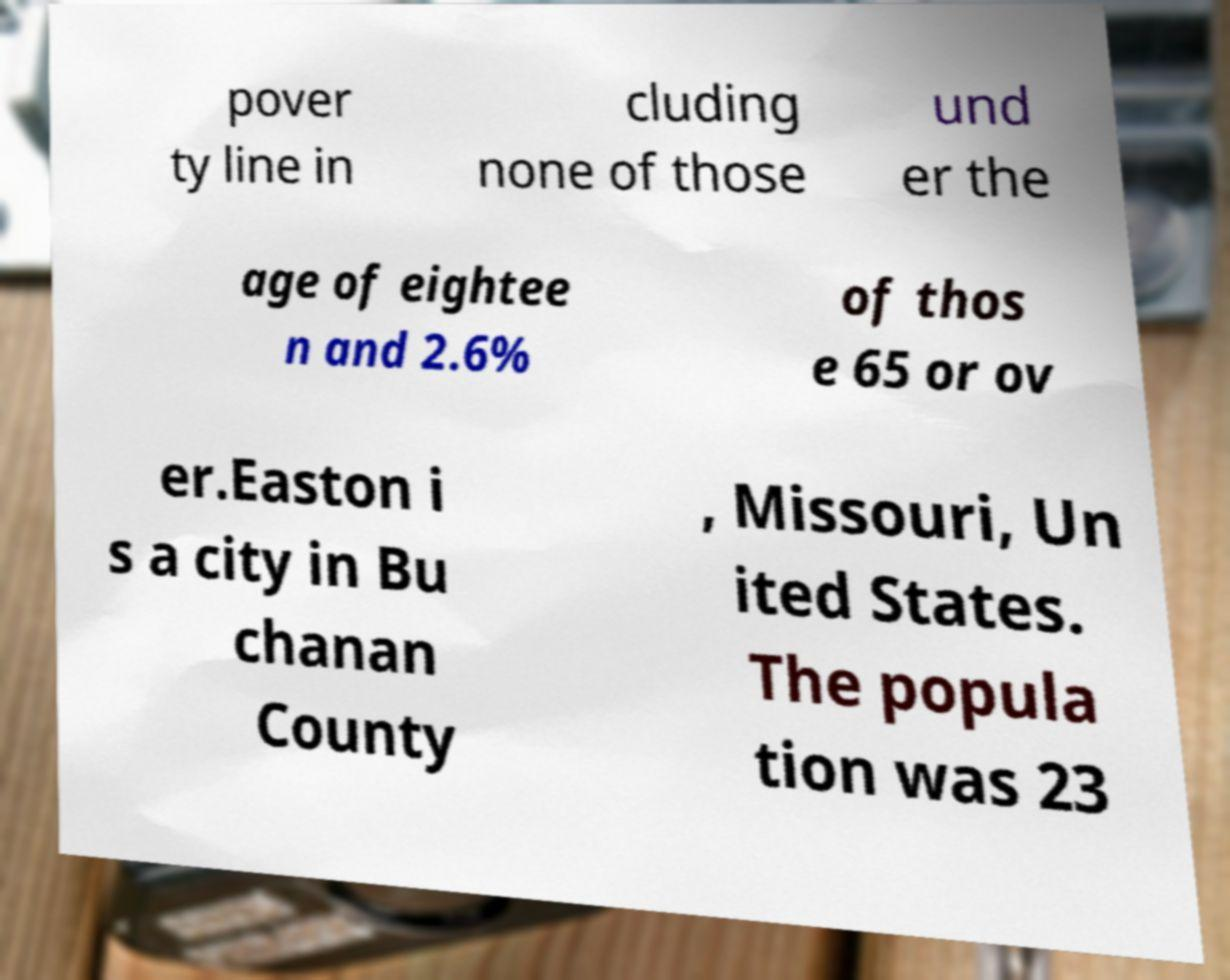For documentation purposes, I need the text within this image transcribed. Could you provide that? pover ty line in cluding none of those und er the age of eightee n and 2.6% of thos e 65 or ov er.Easton i s a city in Bu chanan County , Missouri, Un ited States. The popula tion was 23 